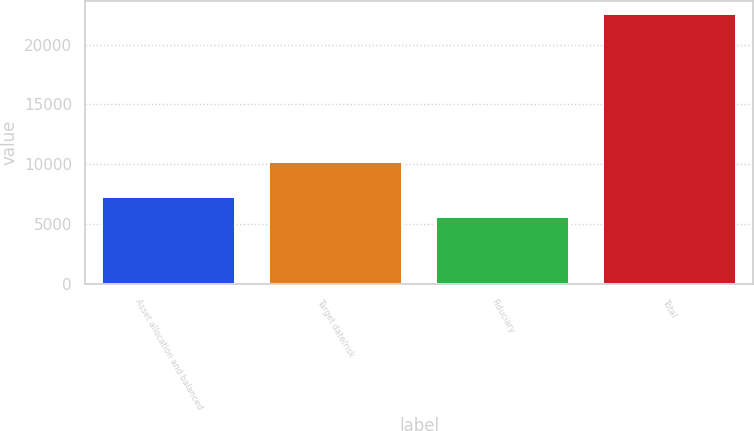<chart> <loc_0><loc_0><loc_500><loc_500><bar_chart><fcel>Asset allocation and balanced<fcel>Target date/risk<fcel>Fiduciary<fcel>Total<nl><fcel>7278.5<fcel>10189<fcel>5585<fcel>22520<nl></chart> 